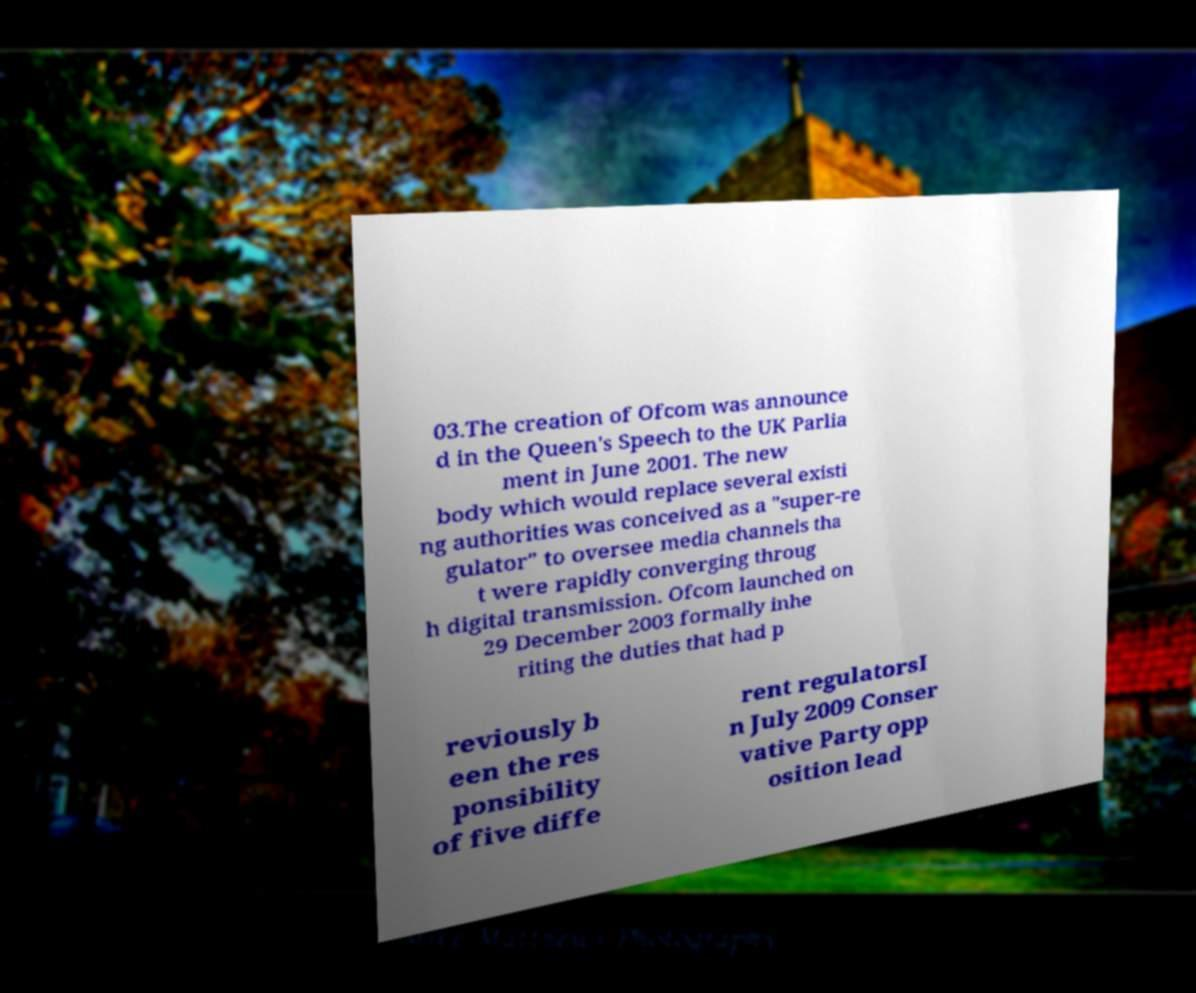What messages or text are displayed in this image? I need them in a readable, typed format. 03.The creation of Ofcom was announce d in the Queen's Speech to the UK Parlia ment in June 2001. The new body which would replace several existi ng authorities was conceived as a "super-re gulator" to oversee media channels tha t were rapidly converging throug h digital transmission. Ofcom launched on 29 December 2003 formally inhe riting the duties that had p reviously b een the res ponsibility of five diffe rent regulatorsI n July 2009 Conser vative Party opp osition lead 